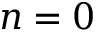<formula> <loc_0><loc_0><loc_500><loc_500>n = 0</formula> 